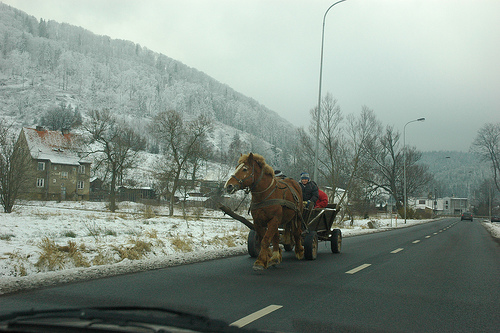<image>
Can you confirm if the horse is under the person? No. The horse is not positioned under the person. The vertical relationship between these objects is different. 